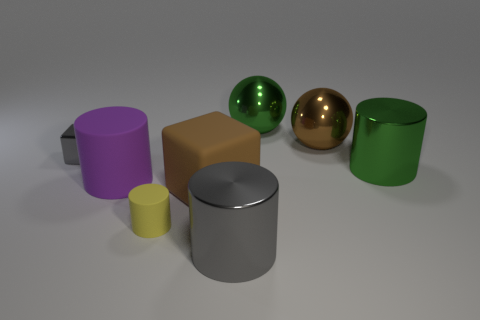Subtract all large gray shiny cylinders. How many cylinders are left? 3 Subtract all brown blocks. How many blocks are left? 1 Subtract 1 spheres. How many spheres are left? 1 Subtract all balls. How many objects are left? 6 Add 1 gray spheres. How many objects exist? 9 Subtract 0 blue cubes. How many objects are left? 8 Subtract all yellow cylinders. Subtract all brown spheres. How many cylinders are left? 3 Subtract all green blocks. How many red balls are left? 0 Subtract all metal cylinders. Subtract all big gray shiny cylinders. How many objects are left? 5 Add 5 small yellow matte objects. How many small yellow matte objects are left? 6 